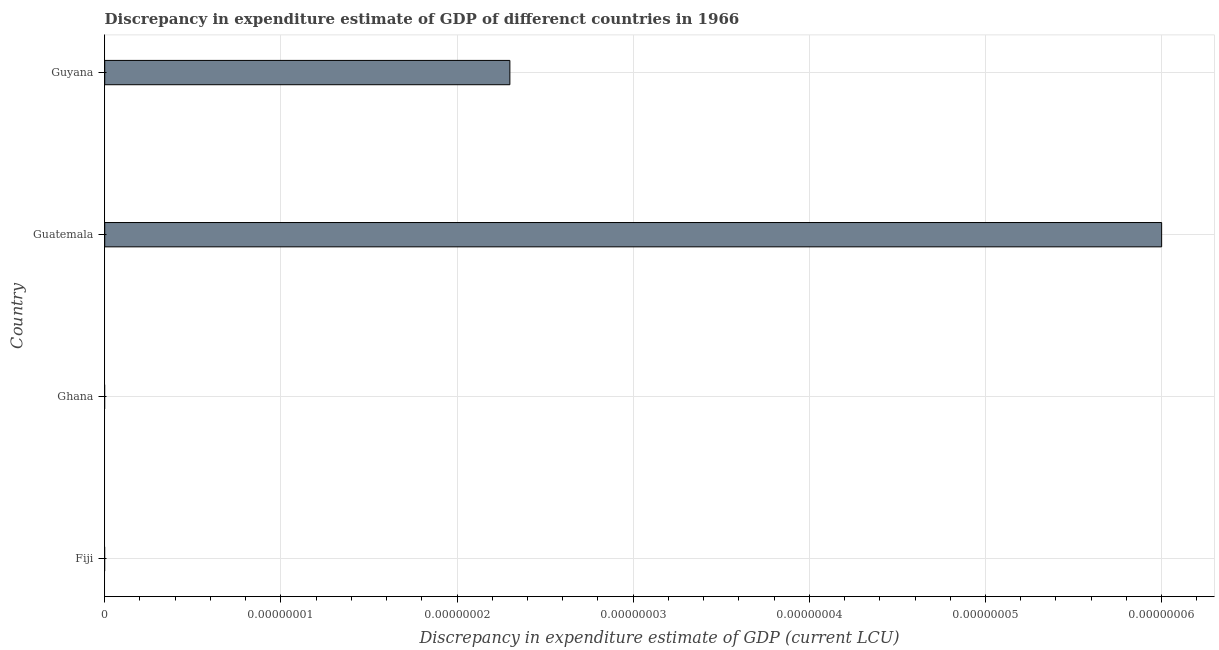What is the title of the graph?
Provide a short and direct response. Discrepancy in expenditure estimate of GDP of differenct countries in 1966. What is the label or title of the X-axis?
Your answer should be very brief. Discrepancy in expenditure estimate of GDP (current LCU). What is the label or title of the Y-axis?
Ensure brevity in your answer.  Country. What is the discrepancy in expenditure estimate of gdp in Guatemala?
Offer a very short reply. 6e-8. Across all countries, what is the maximum discrepancy in expenditure estimate of gdp?
Provide a succinct answer. 6e-8. In which country was the discrepancy in expenditure estimate of gdp maximum?
Ensure brevity in your answer.  Guatemala. What is the sum of the discrepancy in expenditure estimate of gdp?
Give a very brief answer. 8.299999999999999e-8. What is the difference between the discrepancy in expenditure estimate of gdp in Guatemala and Guyana?
Offer a very short reply. 0. What is the median discrepancy in expenditure estimate of gdp?
Give a very brief answer. 1.15e-8. In how many countries, is the discrepancy in expenditure estimate of gdp greater than 2.4e-08 LCU?
Ensure brevity in your answer.  1. What is the difference between the highest and the lowest discrepancy in expenditure estimate of gdp?
Your answer should be compact. 0. How many bars are there?
Provide a succinct answer. 2. Are all the bars in the graph horizontal?
Offer a very short reply. Yes. What is the difference between two consecutive major ticks on the X-axis?
Make the answer very short. 1e-8. What is the Discrepancy in expenditure estimate of GDP (current LCU) in Ghana?
Provide a short and direct response. 0. What is the Discrepancy in expenditure estimate of GDP (current LCU) in Guatemala?
Keep it short and to the point. 6e-8. What is the Discrepancy in expenditure estimate of GDP (current LCU) in Guyana?
Ensure brevity in your answer.  2.3e-8. What is the ratio of the Discrepancy in expenditure estimate of GDP (current LCU) in Guatemala to that in Guyana?
Offer a terse response. 2.61. 